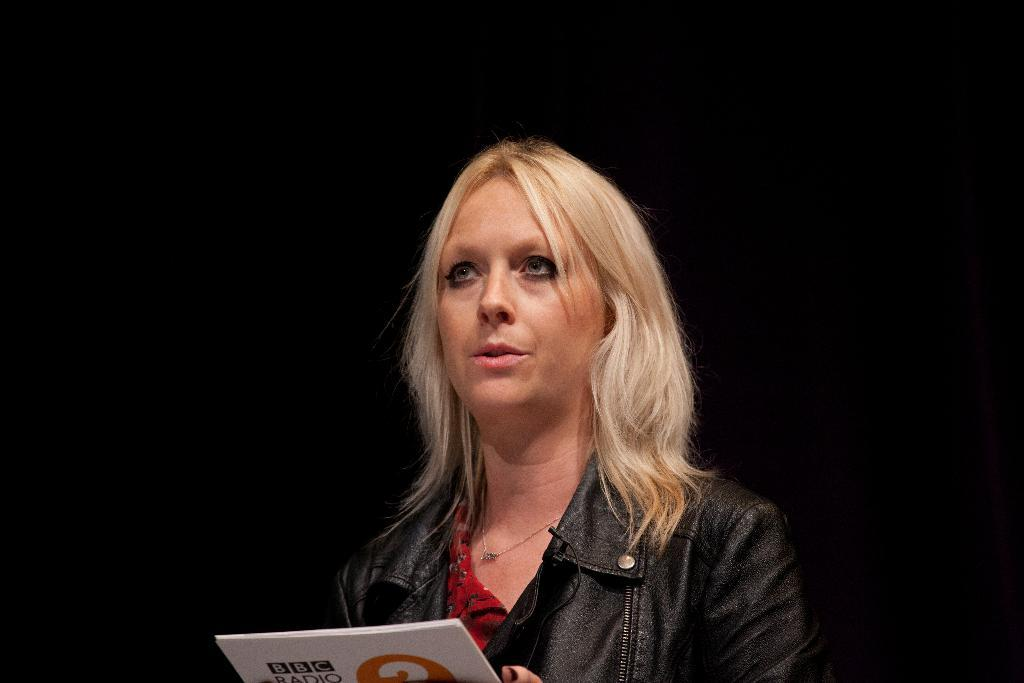Who is the main subject in the image? There is a woman in the image. What is the woman doing in the image? The woman is catching a paper. What type of zipper can be seen on the woman's clothing in the image? There is no zipper visible on the woman's clothing in the image. What news event is the woman reacting to in the image? The image does not provide any information about a news event or the woman's reaction to one. 